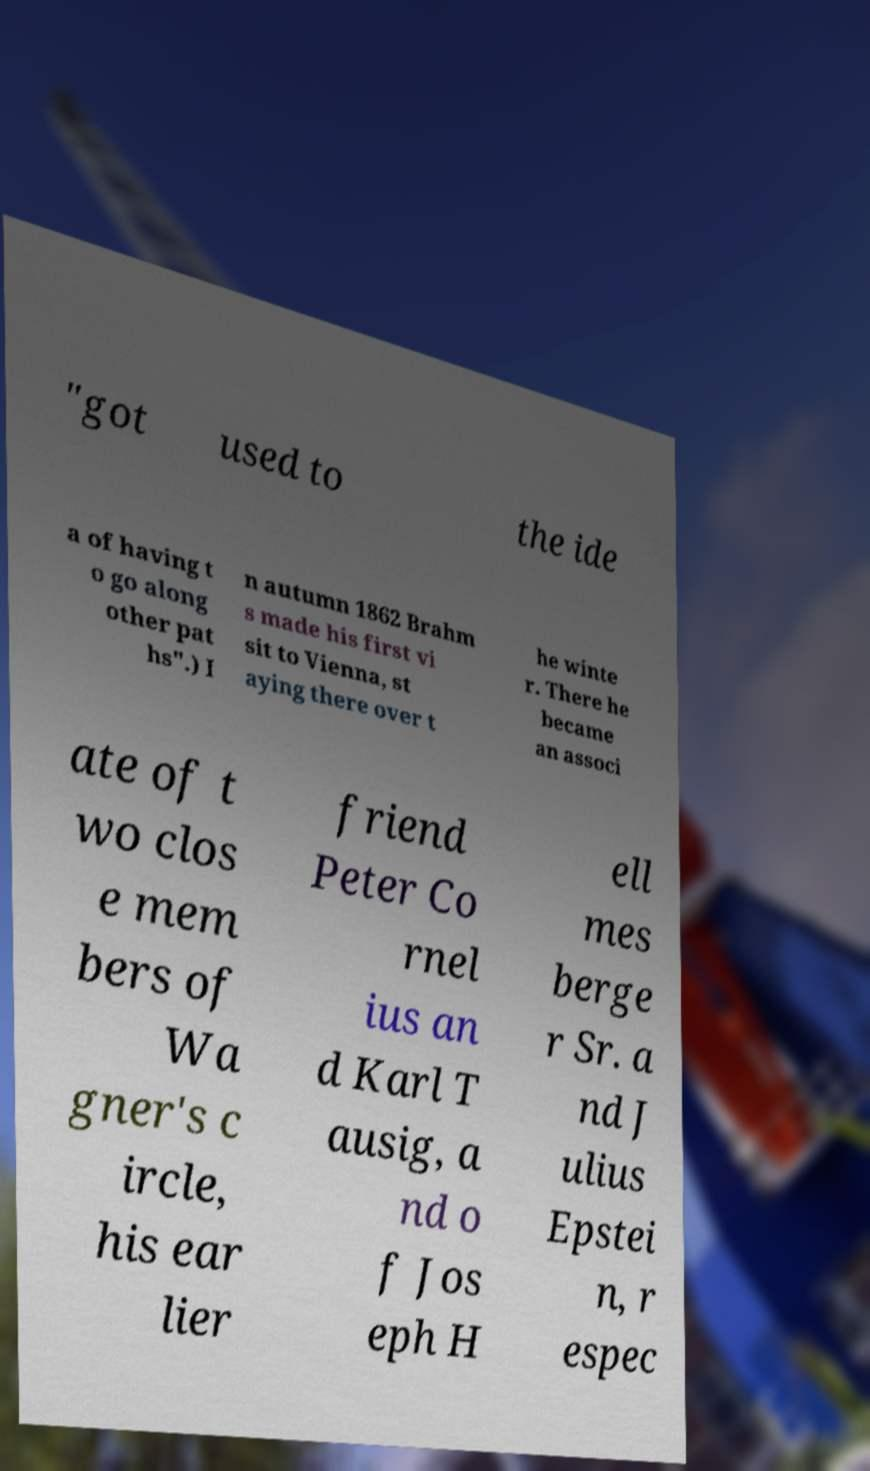What messages or text are displayed in this image? I need them in a readable, typed format. "got used to the ide a of having t o go along other pat hs".) I n autumn 1862 Brahm s made his first vi sit to Vienna, st aying there over t he winte r. There he became an associ ate of t wo clos e mem bers of Wa gner's c ircle, his ear lier friend Peter Co rnel ius an d Karl T ausig, a nd o f Jos eph H ell mes berge r Sr. a nd J ulius Epstei n, r espec 